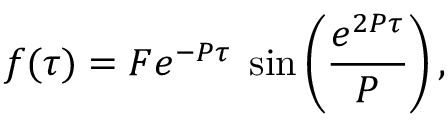<formula> <loc_0><loc_0><loc_500><loc_500>f ( \tau ) = F e ^ { - P \tau } \, \sin \left ( \frac { e ^ { 2 P \tau } } { P } \right ) ,</formula> 